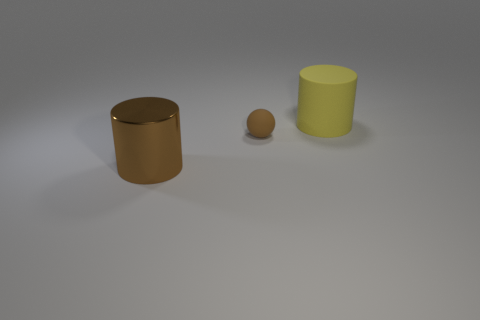Add 3 large green shiny objects. How many objects exist? 6 Subtract all balls. How many objects are left? 2 Add 1 small brown matte balls. How many small brown matte balls are left? 2 Add 1 large brown metallic spheres. How many large brown metallic spheres exist? 1 Subtract 0 blue cylinders. How many objects are left? 3 Subtract all large brown shiny objects. Subtract all big yellow rubber objects. How many objects are left? 1 